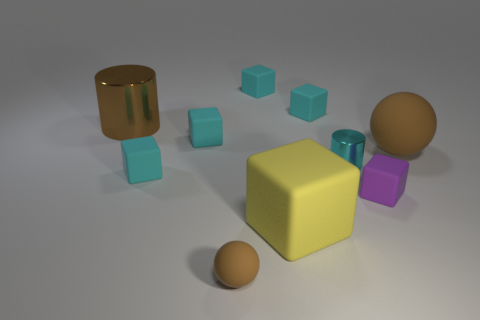How many tiny rubber blocks are there?
Give a very brief answer. 5. Are there fewer yellow rubber cubes on the left side of the yellow matte object than purple rubber things behind the cyan cylinder?
Your answer should be very brief. No. Are there fewer cylinders in front of the large brown cylinder than cylinders?
Make the answer very short. Yes. What material is the brown object to the right of the tiny cyan shiny thing that is in front of the brown ball that is on the right side of the large yellow rubber block?
Provide a succinct answer. Rubber. How many things are brown spheres behind the yellow rubber cube or cyan things that are on the right side of the yellow matte object?
Provide a succinct answer. 3. There is a yellow object that is the same shape as the purple matte object; what material is it?
Keep it short and to the point. Rubber. How many shiny things are blue balls or cyan blocks?
Keep it short and to the point. 0. The tiny purple object that is made of the same material as the large yellow object is what shape?
Your answer should be compact. Cube. What number of matte things have the same shape as the brown metallic thing?
Provide a succinct answer. 0. Does the brown matte thing that is behind the purple matte thing have the same shape as the brown thing that is in front of the tiny purple cube?
Give a very brief answer. Yes. 